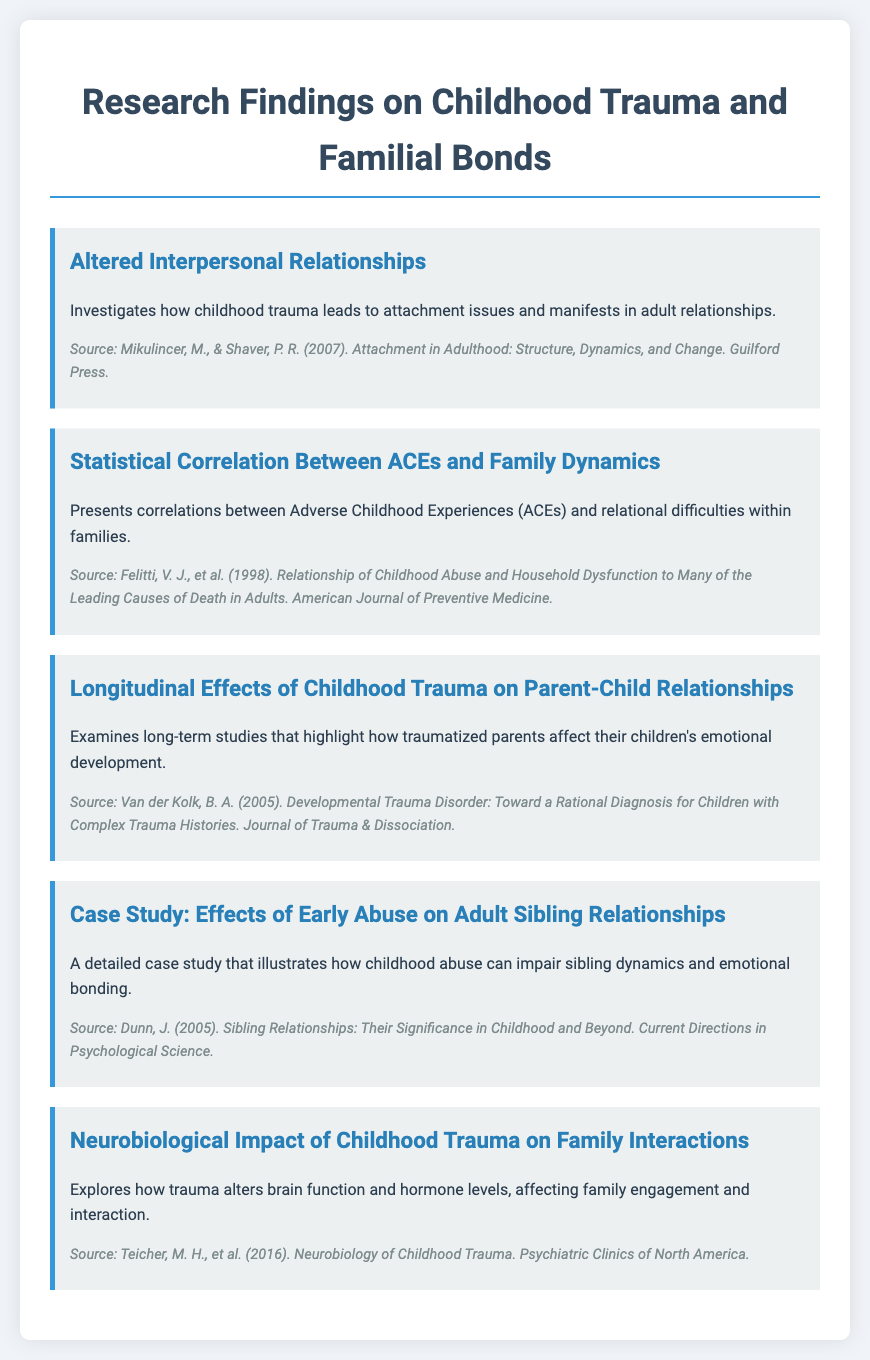what is the first topic listed in the document? The first topic is the first menu item presented, focusing on interpersonal relationships and attachment issues due to childhood trauma.
Answer: Altered Interpersonal Relationships who are the authors of the source related to statistical correlation between ACEs and family dynamics? The authors of this source are the researchers cited for their work on Adverse Childhood Experiences and family dynamics.
Answer: Felitti, V. J., et al how many menu items are presented in the document? The total count of distinct sections or topics covered is found by counting the individual menu items listed.
Answer: Five which case study is mentioned in the document? This refers to the specific case study discussed that illustrates a real-life impact of childhood abuse on sibling relationships.
Answer: Case Study: Effects of Early Abuse on Adult Sibling Relationships what is the source for the neurobiological impact of childhood trauma? This identifies the author or research group associated with the neurobiological effects of trauma on family interactions, as listed in the document.
Answer: Teicher, M. H., et al. (2016) which publication discusses developmental trauma disorder? This question pertains to the source that addresses complex trauma histories in children.
Answer: Journal of Trauma & Dissociation how does childhood trauma affect sibling dynamics according to the case study? This question requires understanding the content of the specific case study presented regarding the outcome of childhood abuse.
Answer: Impair sibling dynamics and emotional bonding what kind of effects are examined in the longitudinal study mentioned? The focus is on the long-term impacts of childhood trauma highlighted in parent-child relationships.
Answer: Emotional development 